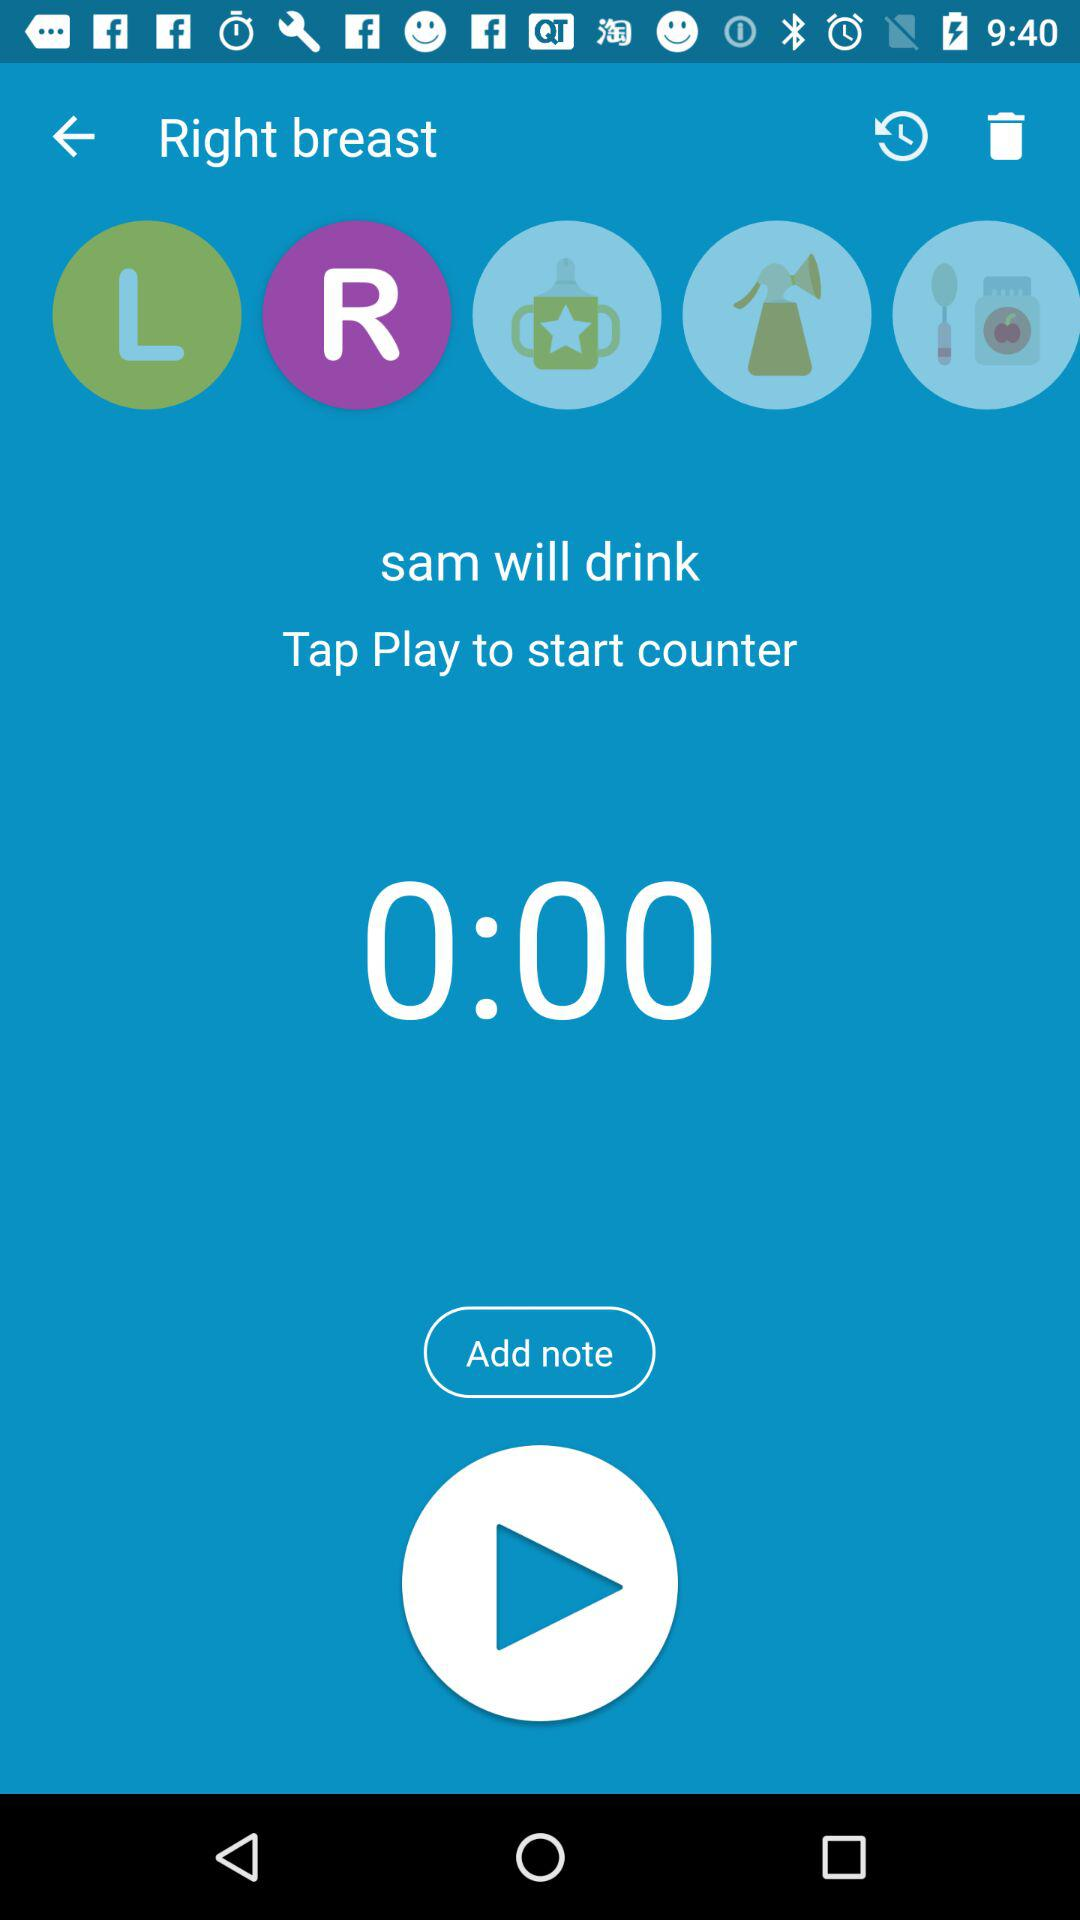What is the user name? The user name is Sam. 